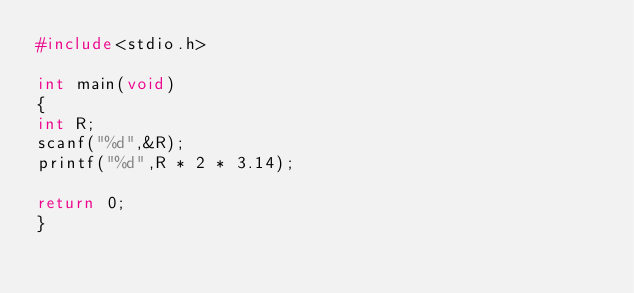Convert code to text. <code><loc_0><loc_0><loc_500><loc_500><_C_>#include<stdio.h>

int main(void)
{
int R;
scanf("%d",&R);
printf("%d",R * 2 * 3.14);

return 0;
}</code> 